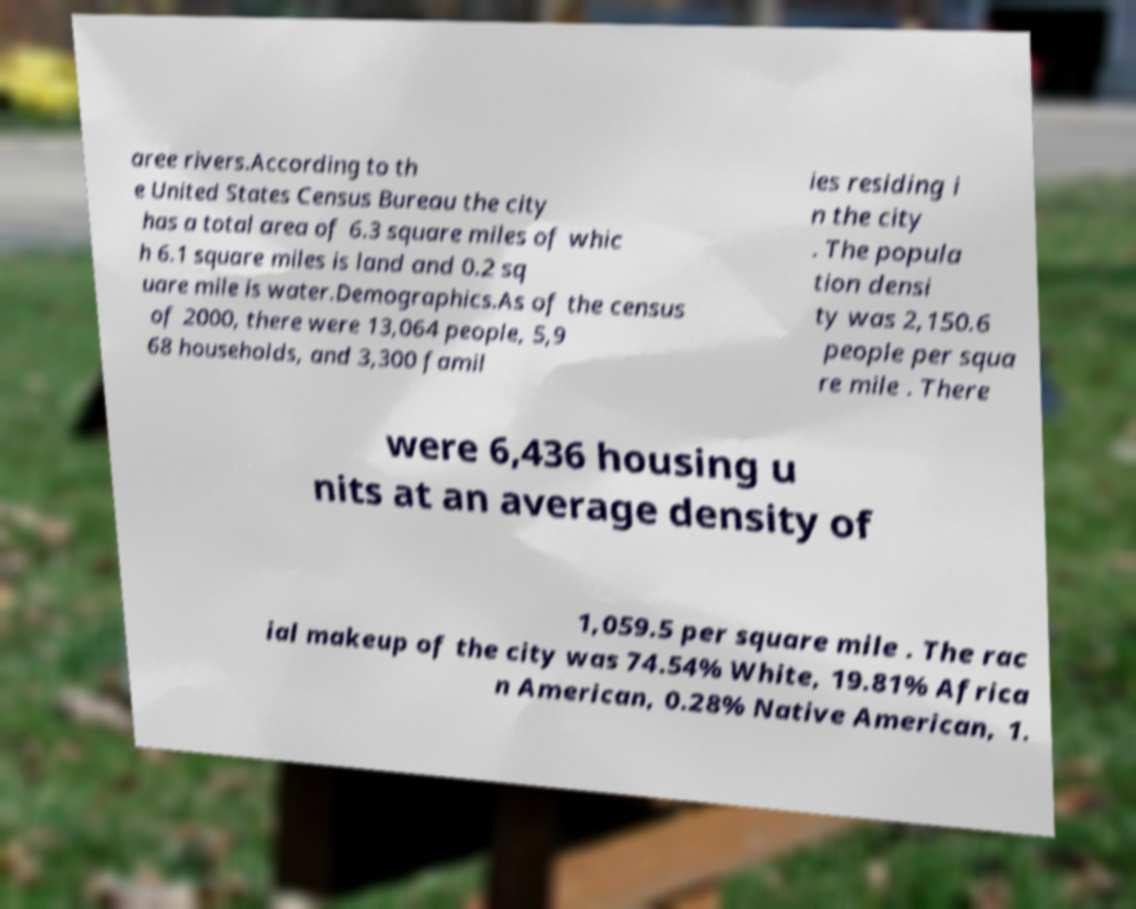Please identify and transcribe the text found in this image. aree rivers.According to th e United States Census Bureau the city has a total area of 6.3 square miles of whic h 6.1 square miles is land and 0.2 sq uare mile is water.Demographics.As of the census of 2000, there were 13,064 people, 5,9 68 households, and 3,300 famil ies residing i n the city . The popula tion densi ty was 2,150.6 people per squa re mile . There were 6,436 housing u nits at an average density of 1,059.5 per square mile . The rac ial makeup of the city was 74.54% White, 19.81% Africa n American, 0.28% Native American, 1. 